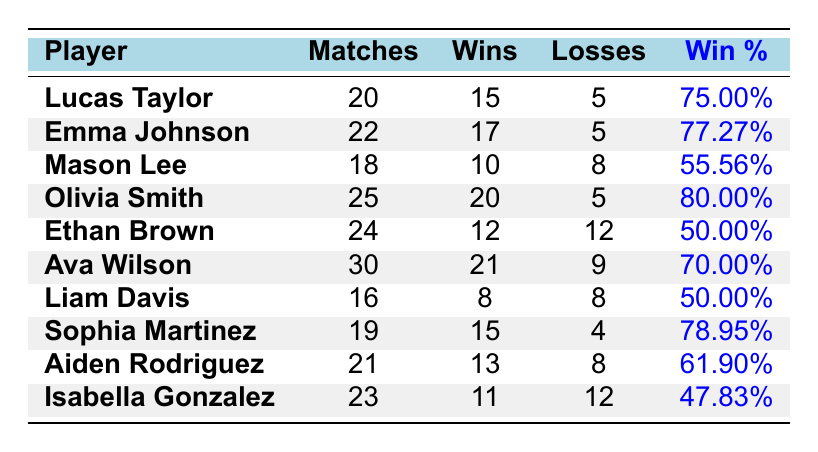What is the win percentage of Olivia Smith? The win percentage is listed directly next to her name in the table. It shows that Olivia has a win percentage of 80.00%.
Answer: 80.00% Who has the highest number of matches played? The table lists all players along with the number of matches they played. By looking through this column, Olivia Smith has played the most matches with a total of 25.
Answer: Olivia Smith How many wins did Emma Johnson achieve? The number of wins for each player is specified in the table. For Emma Johnson, it shows that she has 17 wins.
Answer: 17 Is Aiden Rodriguez's win percentage higher than Liam Davis's? By checking the win percentages listed, Aiden Rodriguez has a win percentage of 61.90% while Liam Davis has a win percentage of 50.00%. Since 61.90% is greater than 50.00%, the answer is yes.
Answer: Yes What is the average number of losses among all players? To find the average, sum the losses: (5 + 5 + 8 + 5 + 12 + 9 + 8 + 4 + 8 + 12) = 72. There are 10 players, so divide the total losses by the number of players: 72 / 10 = 7.2.
Answer: 7.2 How many players have a win percentage of 75% or higher? Checking the win percentages, Lucas Taylor (75.00%), Emma Johnson (77.27%), Olivia Smith (80.00%), Sophia Martinez (78.95%), and Ava Wilson (70.00%) meet the criteria. So, there are 5 players above 75%.
Answer: 5 Has Mason Lee won more matches than Isabella Gonzalez? From the table, Mason Lee has 10 wins while Isabella Gonzalez has 11 wins. Since 10 is less than 11, the answer is no.
Answer: No What is the difference in the number of wins between Ava Wilson and Ethan Brown? Ava Wilson has 21 wins, and Ethan Brown has 12 wins. To find the difference, subtract: 21 - 12 = 9.
Answer: 9 Which player has the closest record of wins and losses? By examining the records, Ethan Brown and Liam Davis both have equal numbers of wins and losses at 12 wins and 12 losses for Ethan, and 8 wins and 8 losses for Liam; however, Ethan's record is closest to even since both total 24 matches, making his record (50% win rate) logically more aligned, thus he is compared directly on wins and losses.
Answer: Ethan Brown 